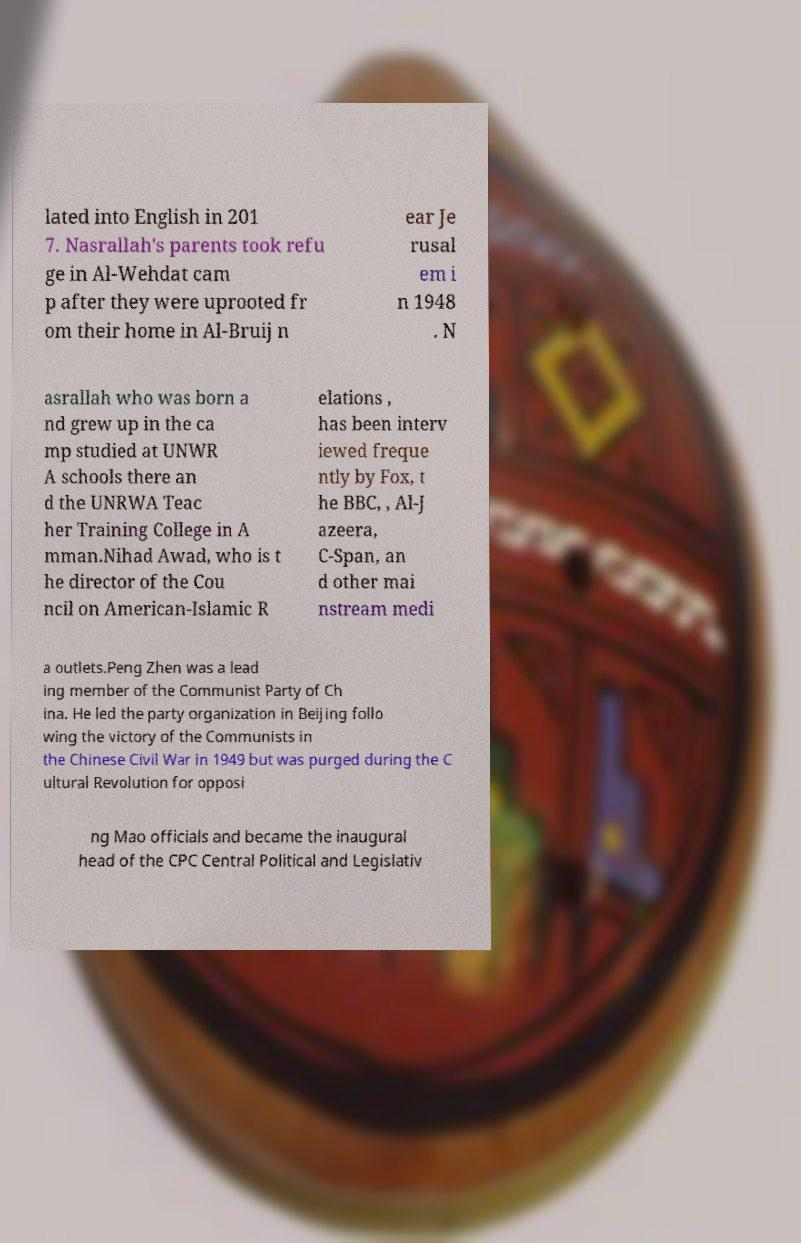What messages or text are displayed in this image? I need them in a readable, typed format. lated into English in 201 7. Nasrallah's parents took refu ge in Al-Wehdat cam p after they were uprooted fr om their home in Al-Bruij n ear Je rusal em i n 1948 . N asrallah who was born a nd grew up in the ca mp studied at UNWR A schools there an d the UNRWA Teac her Training College in A mman.Nihad Awad, who is t he director of the Cou ncil on American-Islamic R elations , has been interv iewed freque ntly by Fox, t he BBC, , Al-J azeera, C-Span, an d other mai nstream medi a outlets.Peng Zhen was a lead ing member of the Communist Party of Ch ina. He led the party organization in Beijing follo wing the victory of the Communists in the Chinese Civil War in 1949 but was purged during the C ultural Revolution for opposi ng Mao officials and became the inaugural head of the CPC Central Political and Legislativ 